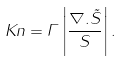<formula> <loc_0><loc_0><loc_500><loc_500>K n = \Gamma \left | \frac { \nabla . \vec { S } } { S } \right | .</formula> 